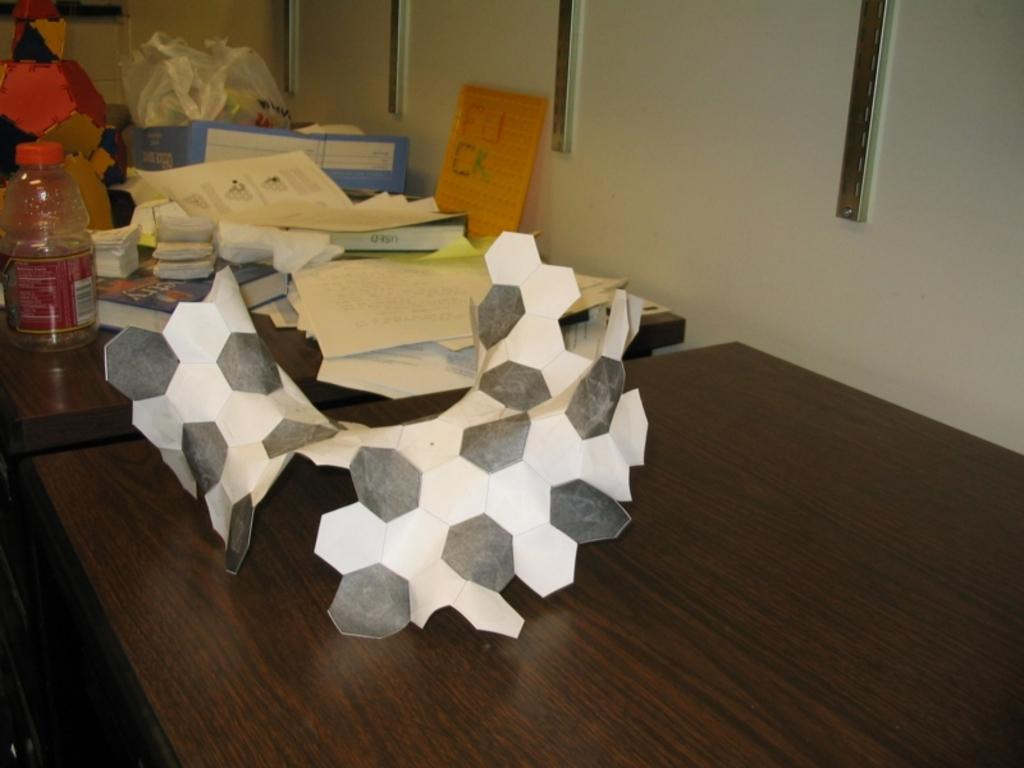What type of furniture is present in the image? There are tables in the image. What can be seen on top of the tables? There is a bottle, posters, and books on the tables. What activity is suggested by the presence of craft in the image? The presence of craft suggests a creative or artistic activity. What is the material of the objects on the wall? The wall has metal objects in the image. How many dolls are sitting on the tables in the image? There are no dolls present in the image. What type of basin is visible in the image? There is no basin visible in the image. 